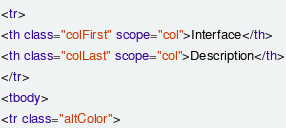Convert code to text. <code><loc_0><loc_0><loc_500><loc_500><_HTML_><tr>
<th class="colFirst" scope="col">Interface</th>
<th class="colLast" scope="col">Description</th>
</tr>
<tbody>
<tr class="altColor"></code> 